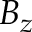<formula> <loc_0><loc_0><loc_500><loc_500>B _ { z }</formula> 